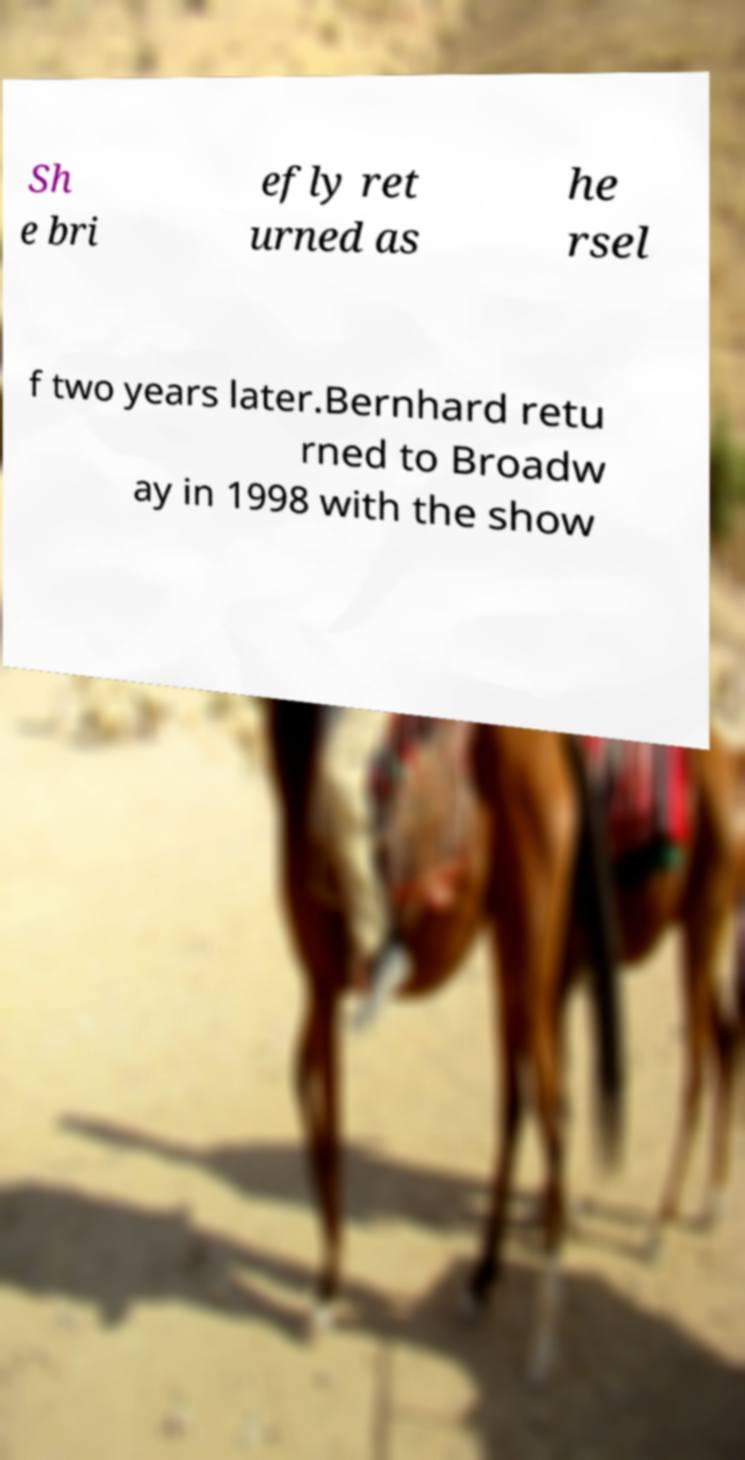Can you accurately transcribe the text from the provided image for me? Sh e bri efly ret urned as he rsel f two years later.Bernhard retu rned to Broadw ay in 1998 with the show 